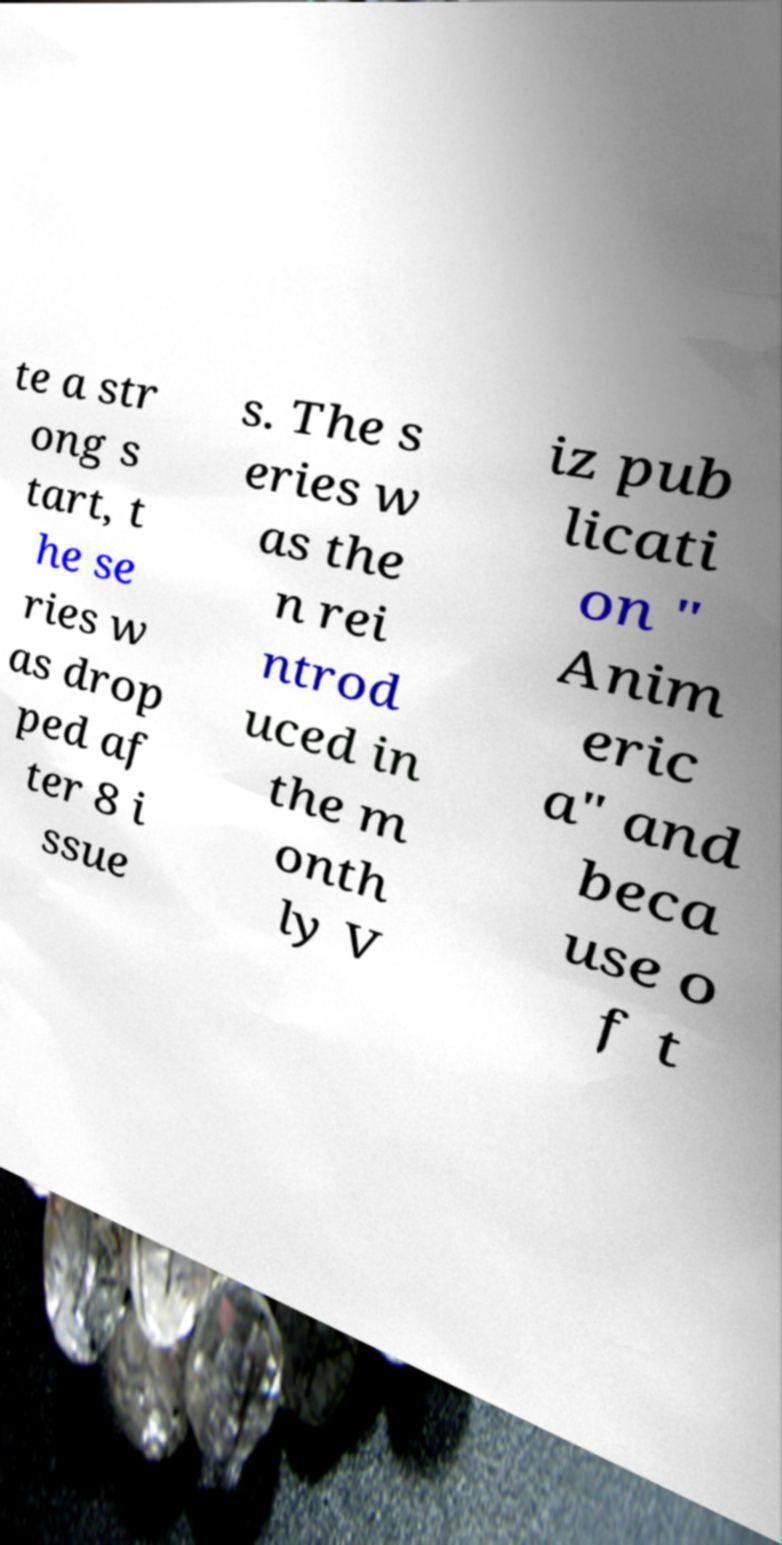Please identify and transcribe the text found in this image. te a str ong s tart, t he se ries w as drop ped af ter 8 i ssue s. The s eries w as the n rei ntrod uced in the m onth ly V iz pub licati on " Anim eric a" and beca use o f t 